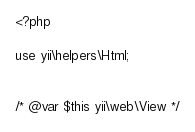Convert code to text. <code><loc_0><loc_0><loc_500><loc_500><_PHP_><?php

use yii\helpers\Html;


/* @var $this yii\web\View */</code> 